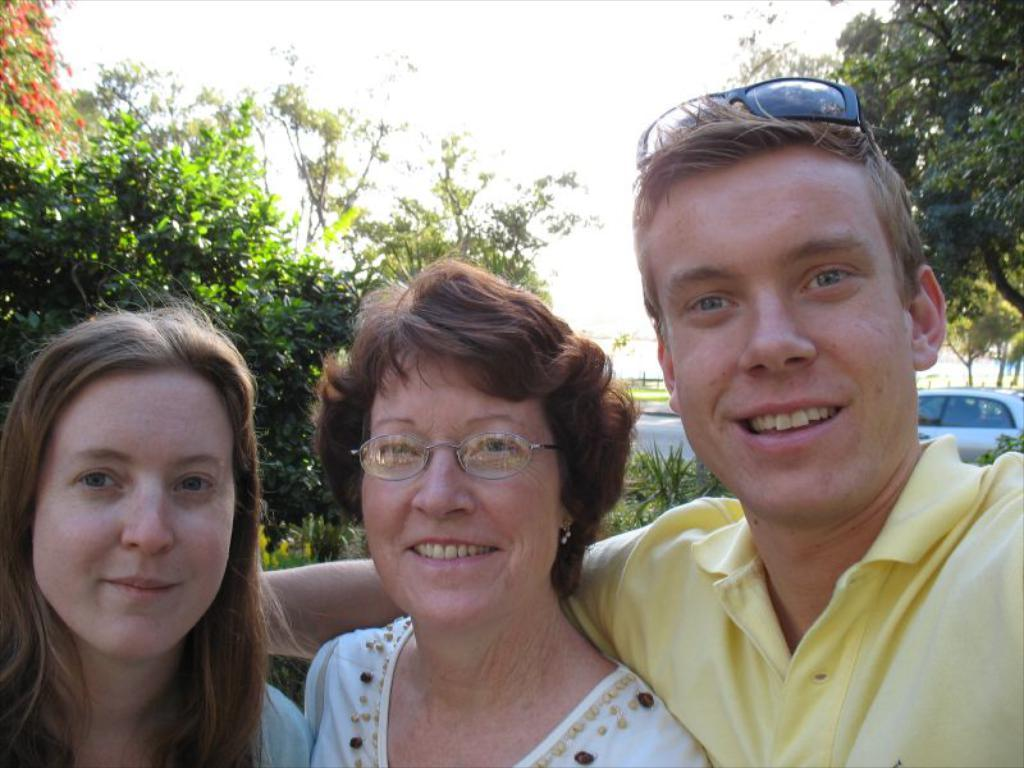Who or what can be seen in the front of the image? There are persons in the front of the image. What is the facial expression of the persons in the image? The persons are smiling. What type of vegetation is visible in the background of the image? There are trees in the background of the image. What mode of transportation can be seen in the background of the image? There is a car on the road in the background of the image. What type of ground surface is present in the image? There is grass on the ground in the image. What type of oatmeal is being served in the image? There is no oatmeal present in the image. Can you see a bear interacting with the persons in the image? There is no bear present in the image. 